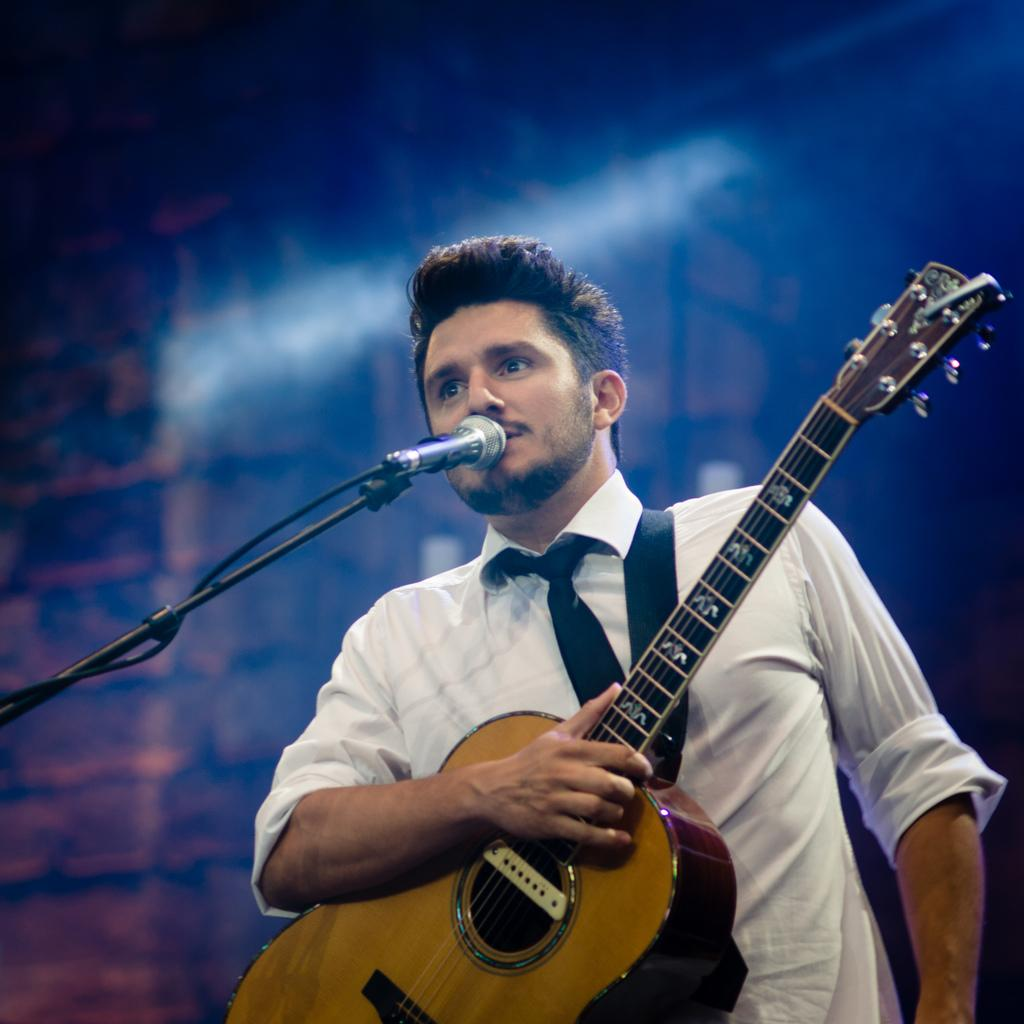Who is the main subject in the image? There is a man in the image. What is the man wearing? The man is wearing a white shirt. What is the man holding in his right hand? The man is holding a guitar in his right hand. What object is in front of the man? There is a microphone stand in front of the man. What type of structure can be seen in the background of the image? There is no structure visible in the background of the image. How does the man push the guitar to create a unique sound? The man is not pushing the guitar in the image; he is holding it in his right hand. 